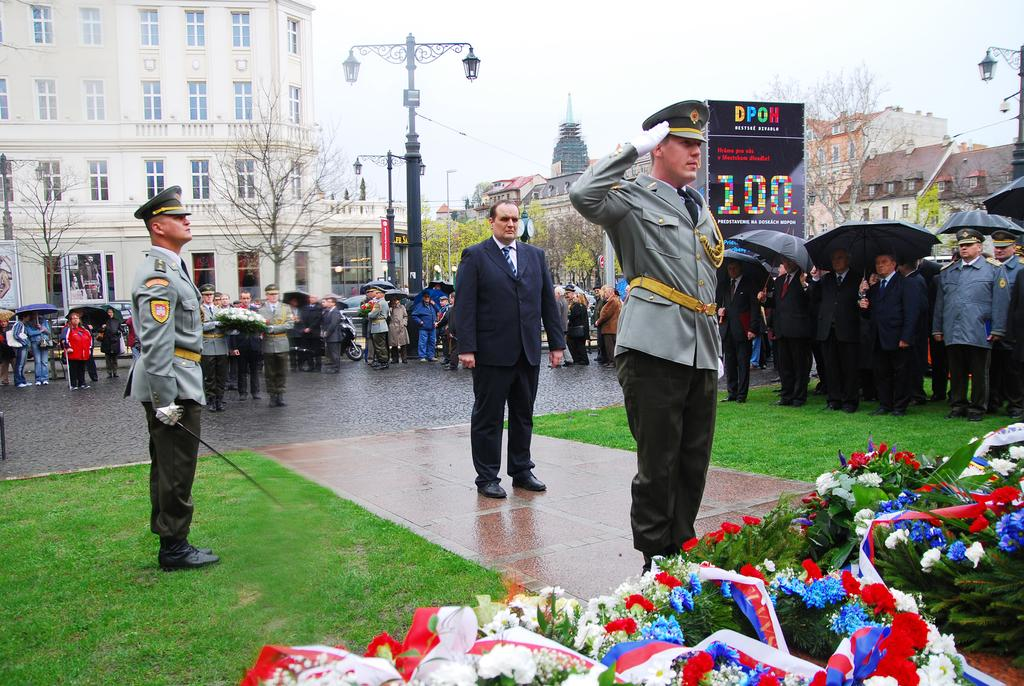What can be seen in the image? There are people standing in the image, along with lights on poles, flowers, grass, and trees in the background. What is visible in the background of the image? In the background of the image, there are trees, buildings, and the sky. What type of vegetation is present in the image? The image features flowers and grass. Can you tell me who the creator of the flowers is in the image? The image does not provide information about the creator of the flowers; it only shows their presence. Is there an airplane visible in the image? No, there is no airplane present in the image. How many clovers can be seen in the image? There are no clovers visible in the image. 